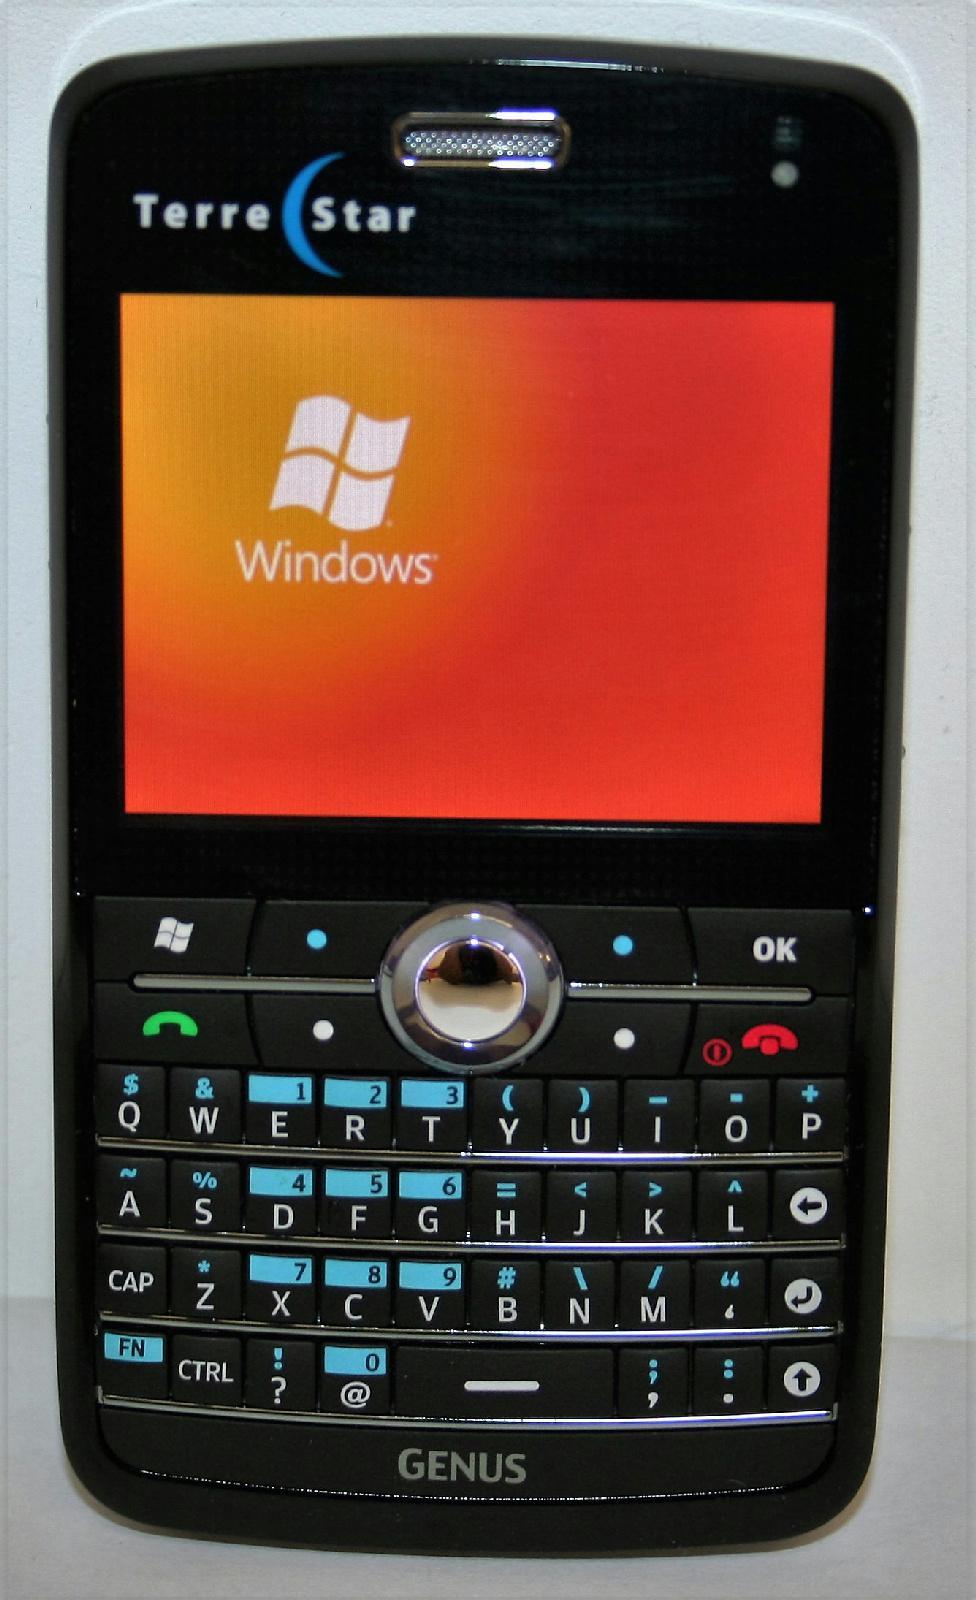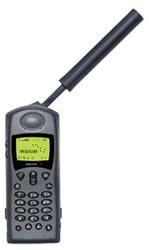The first image is the image on the left, the second image is the image on the right. Given the left and right images, does the statement "There are at least three phones." hold true? Answer yes or no. No. The first image is the image on the left, the second image is the image on the right. Evaluate the accuracy of this statement regarding the images: "One image contains a single black device, which is upright and has a rod-shape extending diagonally from its top.". Is it true? Answer yes or no. Yes. 